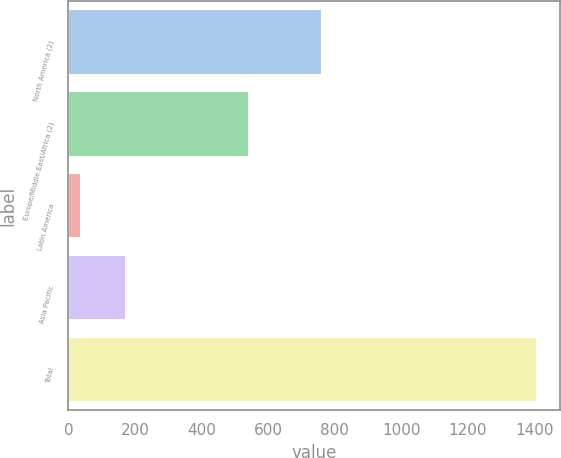<chart> <loc_0><loc_0><loc_500><loc_500><bar_chart><fcel>North America (2)<fcel>Europe/Middle East/Africa (2)<fcel>Latin America<fcel>Asia Pacific<fcel>Total<nl><fcel>760.7<fcel>543.1<fcel>36.1<fcel>173.27<fcel>1407.8<nl></chart> 